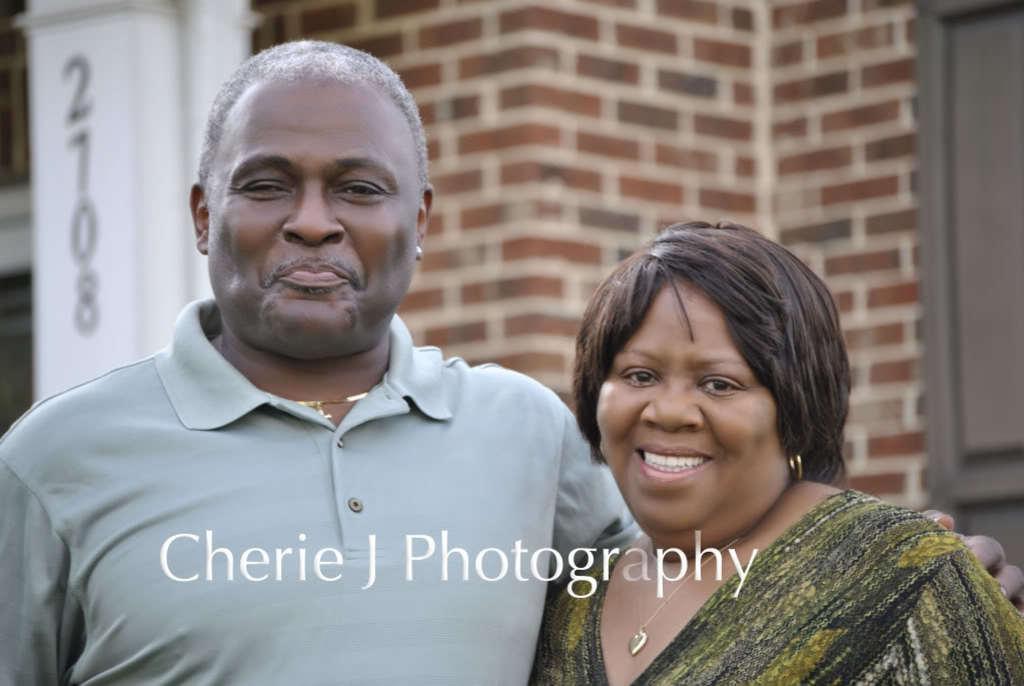Please provide a concise description of this image. Here we can see a man and a woman are smiling. In the background we can see numbers on an object,wall and window doors. 